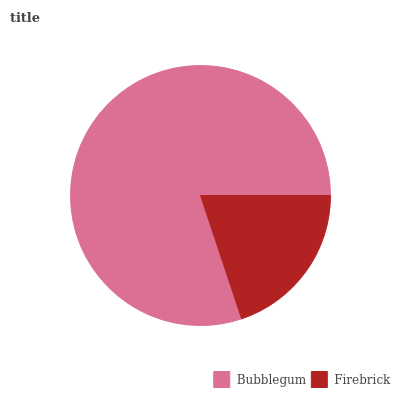Is Firebrick the minimum?
Answer yes or no. Yes. Is Bubblegum the maximum?
Answer yes or no. Yes. Is Firebrick the maximum?
Answer yes or no. No. Is Bubblegum greater than Firebrick?
Answer yes or no. Yes. Is Firebrick less than Bubblegum?
Answer yes or no. Yes. Is Firebrick greater than Bubblegum?
Answer yes or no. No. Is Bubblegum less than Firebrick?
Answer yes or no. No. Is Bubblegum the high median?
Answer yes or no. Yes. Is Firebrick the low median?
Answer yes or no. Yes. Is Firebrick the high median?
Answer yes or no. No. Is Bubblegum the low median?
Answer yes or no. No. 